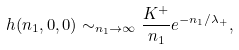<formula> <loc_0><loc_0><loc_500><loc_500>h ( n _ { 1 } , 0 , 0 ) \sim _ { n _ { 1 } \to \infty } \frac { K ^ { + } } { n _ { 1 } } e ^ { - n _ { 1 } / \lambda _ { + } } ,</formula> 